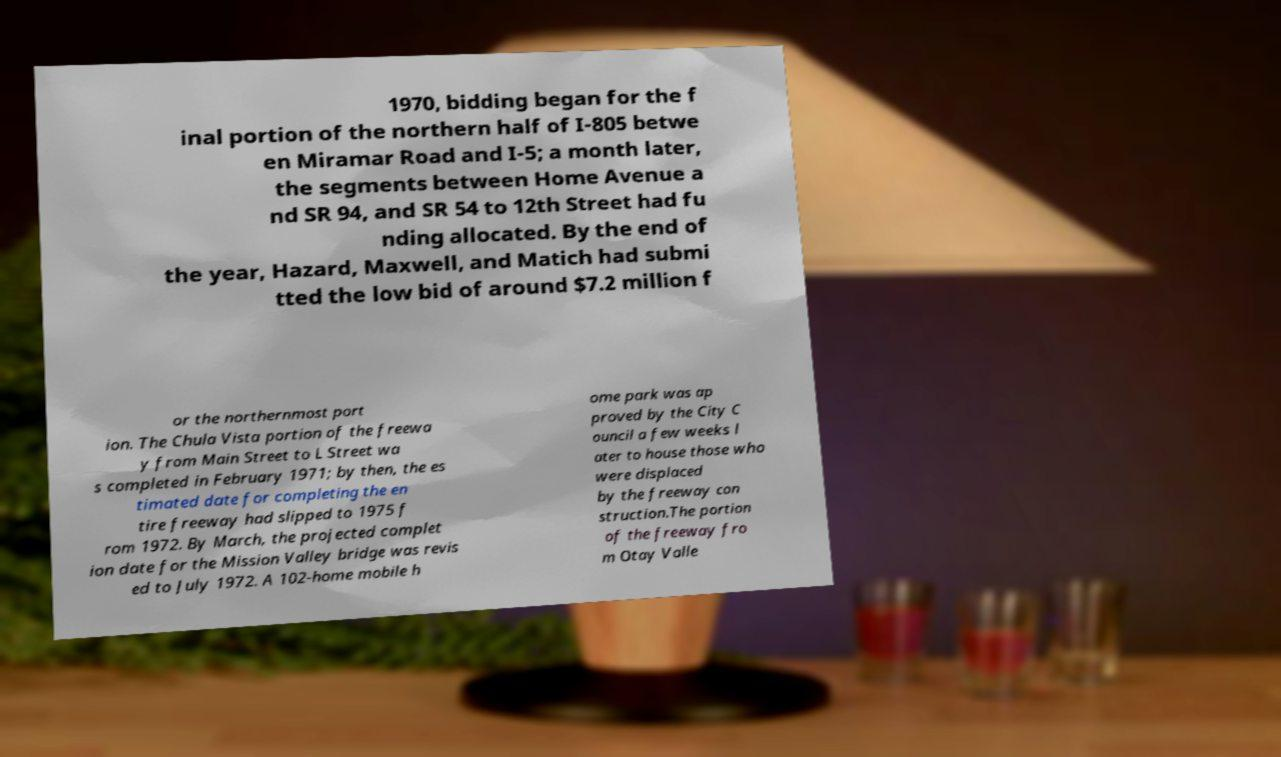I need the written content from this picture converted into text. Can you do that? 1970, bidding began for the f inal portion of the northern half of I-805 betwe en Miramar Road and I-5; a month later, the segments between Home Avenue a nd SR 94, and SR 54 to 12th Street had fu nding allocated. By the end of the year, Hazard, Maxwell, and Matich had submi tted the low bid of around $7.2 million f or the northernmost port ion. The Chula Vista portion of the freewa y from Main Street to L Street wa s completed in February 1971; by then, the es timated date for completing the en tire freeway had slipped to 1975 f rom 1972. By March, the projected complet ion date for the Mission Valley bridge was revis ed to July 1972. A 102-home mobile h ome park was ap proved by the City C ouncil a few weeks l ater to house those who were displaced by the freeway con struction.The portion of the freeway fro m Otay Valle 